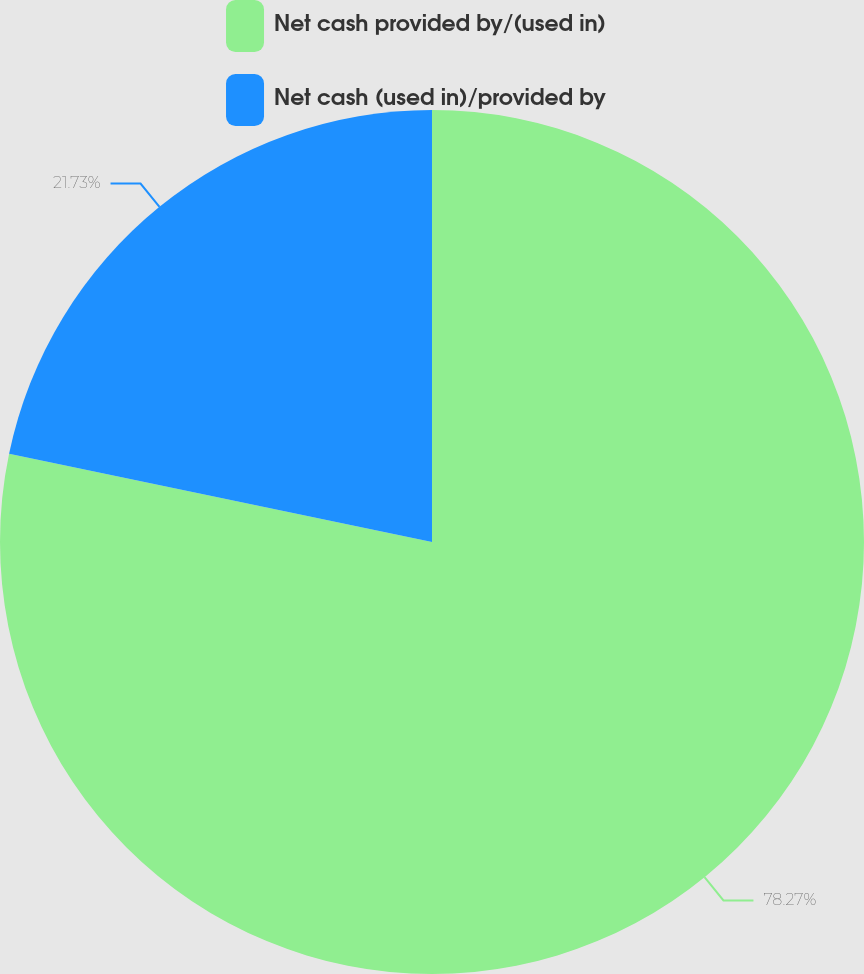Convert chart. <chart><loc_0><loc_0><loc_500><loc_500><pie_chart><fcel>Net cash provided by/(used in)<fcel>Net cash (used in)/provided by<nl><fcel>78.27%<fcel>21.73%<nl></chart> 